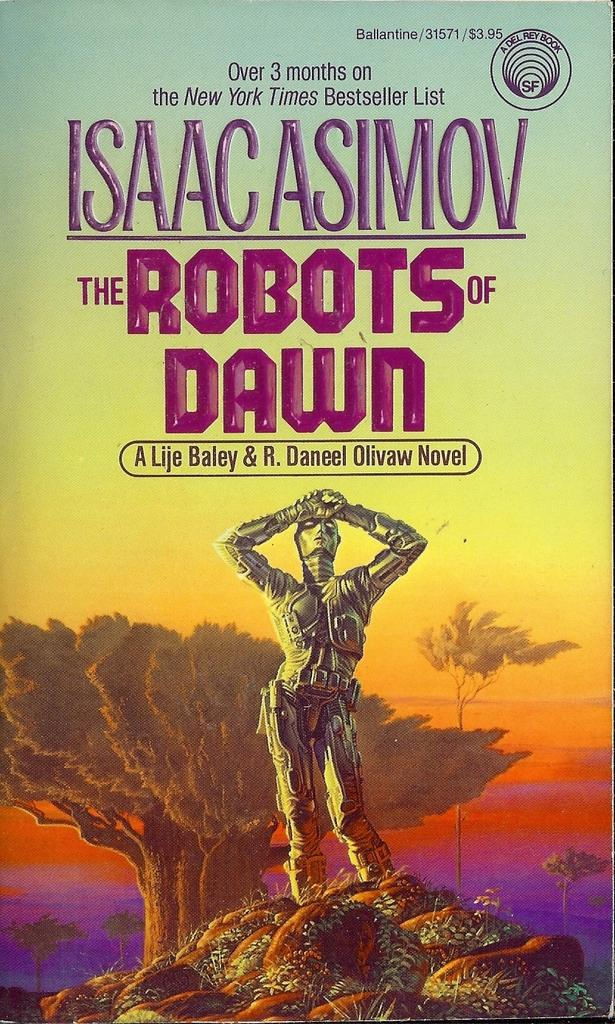<image>
Create a compact narrative representing the image presented. A book by Isaac Asimov called The Robots of Dawn. 